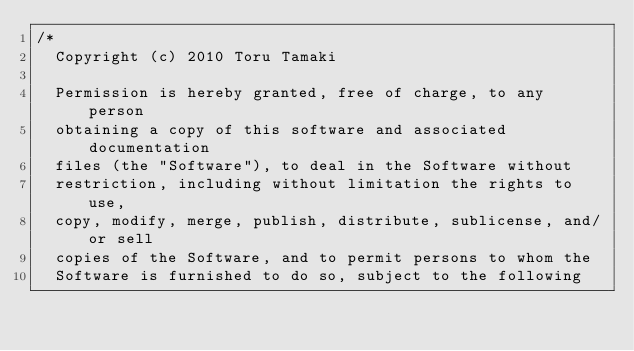<code> <loc_0><loc_0><loc_500><loc_500><_C++_>/*
  Copyright (c) 2010 Toru Tamaki

  Permission is hereby granted, free of charge, to any person
  obtaining a copy of this software and associated documentation
  files (the "Software"), to deal in the Software without
  restriction, including without limitation the rights to use,
  copy, modify, merge, publish, distribute, sublicense, and/or sell
  copies of the Software, and to permit persons to whom the
  Software is furnished to do so, subject to the following</code> 